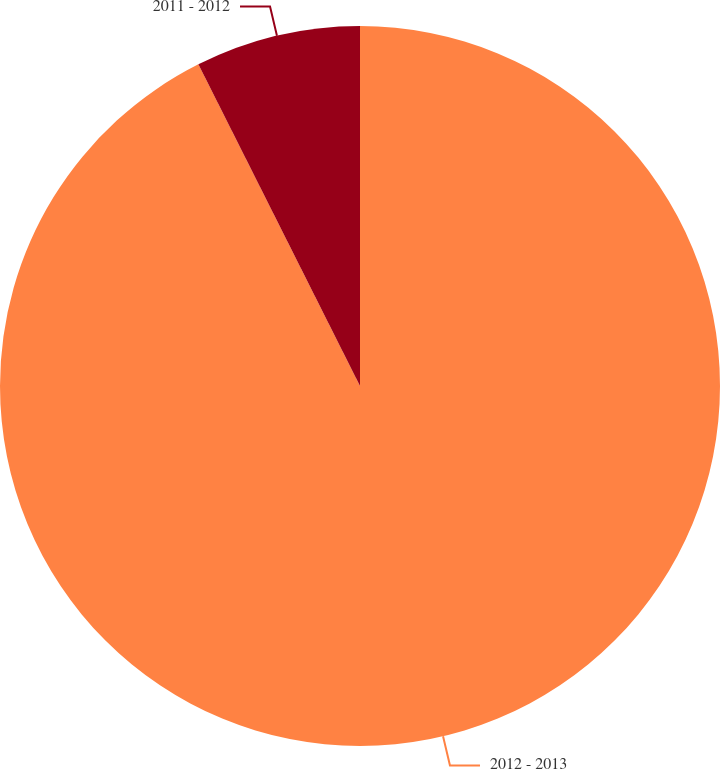Convert chart to OTSL. <chart><loc_0><loc_0><loc_500><loc_500><pie_chart><fcel>2012 - 2013<fcel>2011 - 2012<nl><fcel>92.59%<fcel>7.41%<nl></chart> 